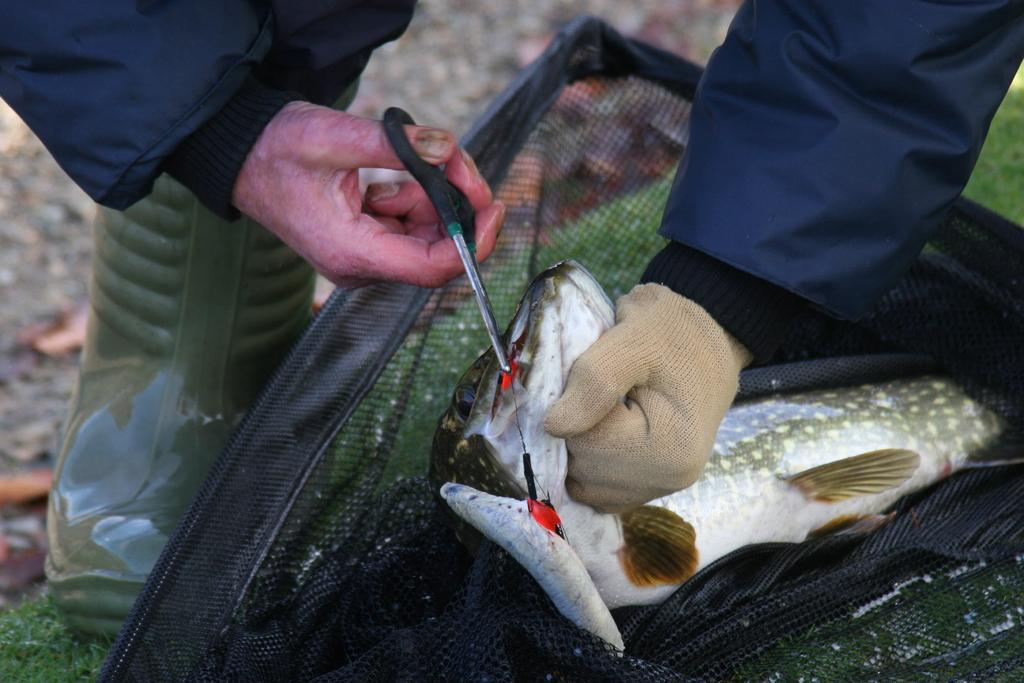Who is present in the image? There is a person in the image. What is the person doing in the image? The person is cutting a fish. What tool is the person using to cut the fish? The person is using a scissor to cut the fish. How many beggars are visible in the image? There are no beggars present in the image; it features a person cutting a fish with a scissor. 